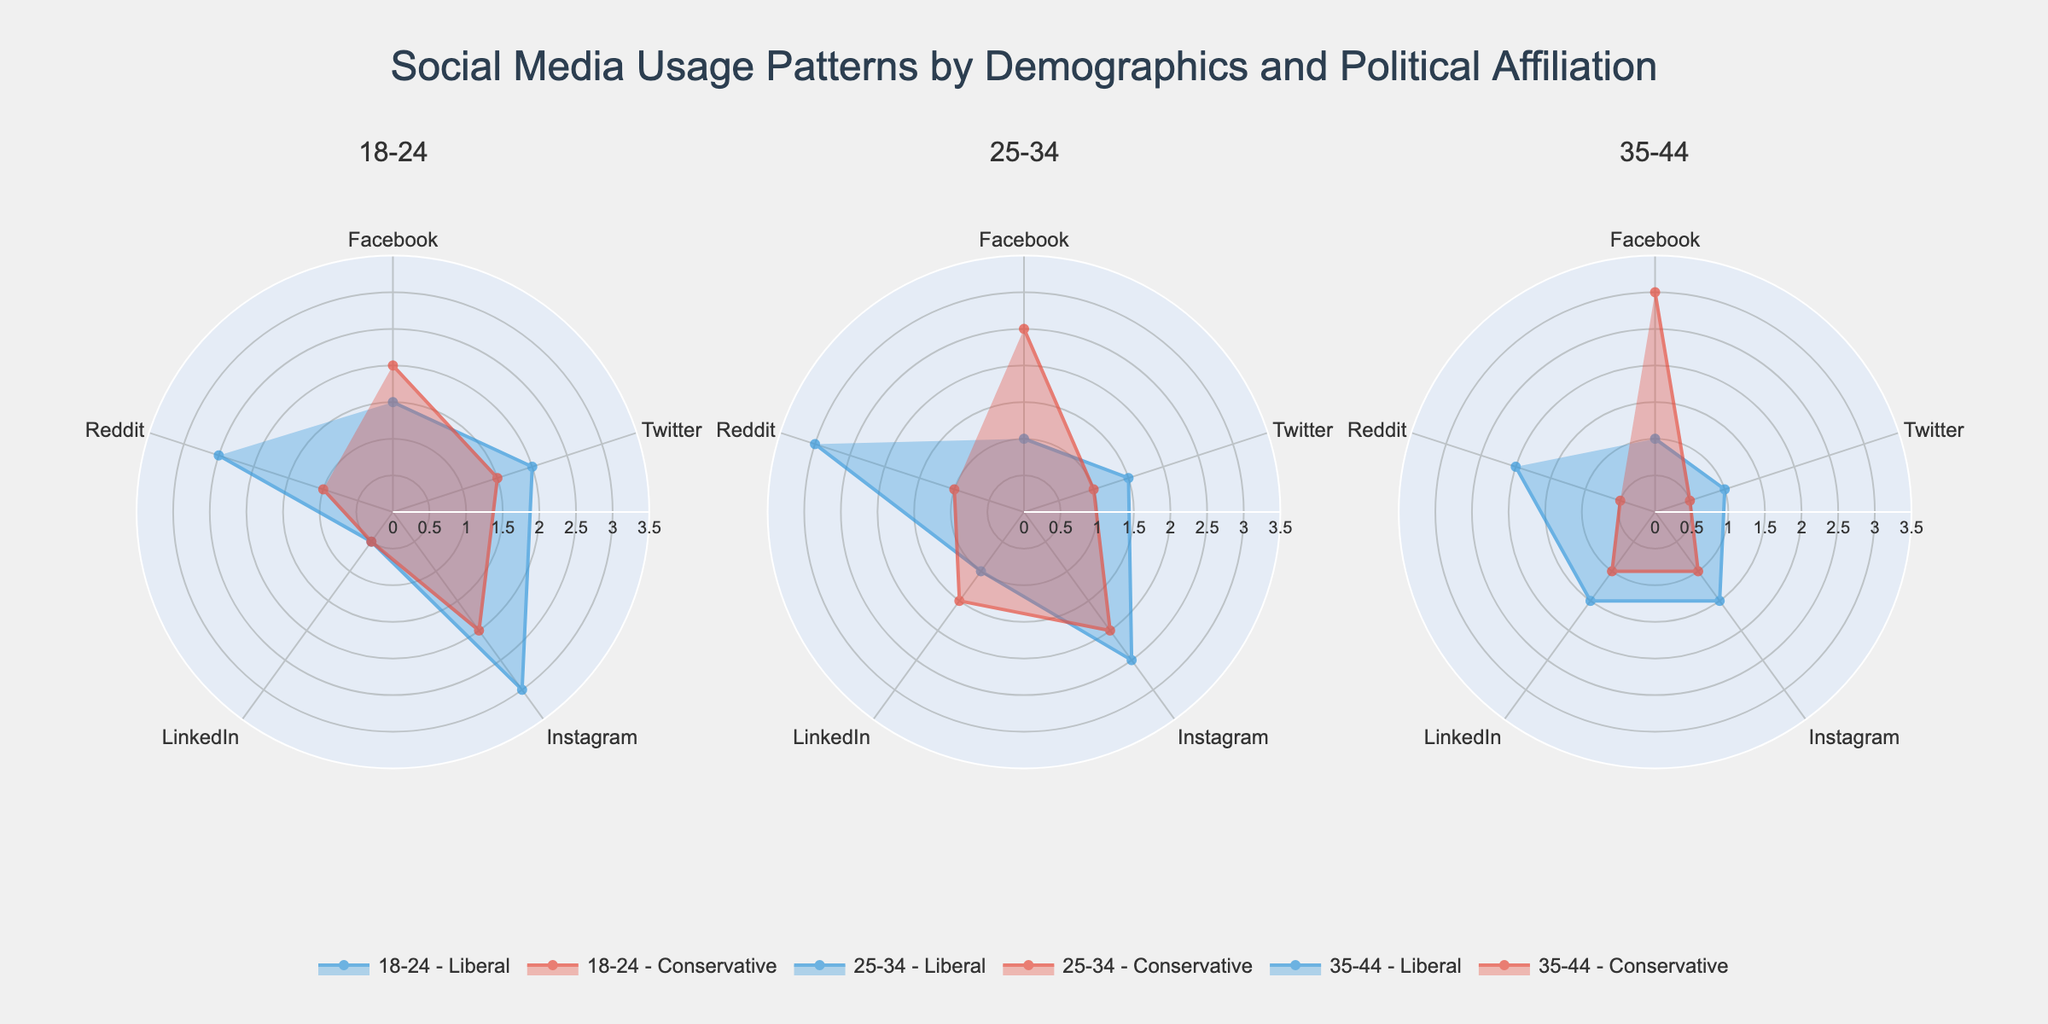Which age group and political affiliation spends the most time on Instagram? By looking at the plot, consider the radial distance for each demographic and political affiliation in relation to Instagram. The 18-24, Liberal group shows the highest radial distance for Instagram with 3.0 hours of average daily usage.
Answer: 18-24, Liberal Which platform has the lowest usage among 35-44 Conservatives? Locate the plot for 35-44 Conservatives and identify the platform with the shortest radial distance. It is indicated that Twitter has the lowest usage with 0.5 hours of average daily usage.
Answer: Twitter Compare the average daily usage of Reddit between 18-24 Liberals and Conservatives. Which group uses it more? Examine the radial distances for Reddit in the 18-24 demographic. The Liberal group has a radial distance of 2.5 hours while the Conservative group has a radial distance of 1.0 hour. Hence, 18-24 Liberals use Reddit more.
Answer: 18-24 Liberals What is the average daily usage of LinkedIn for 25-34 Conservatives? Simply check the radial distance for LinkedIn in the 25-34 Conservative plot within the radar chart. The figure indicates it at 1.5 hours.
Answer: 1.5 hours Which group exhibits the highest overall social media usage (sum of hours across all platforms)? Calculate the sum of hours for each group by adding the radial distances for all platforms. Compare the sums across all groups: 
- 18-24 Liberal: (1.5 + 2.0 + 3.0 + 0.5 + 2.5) = 9.5 
- 18-24 Conservative: (2.0 + 1.5 + 2.0 + 0.5 + 1.0) = 7.0 
- 25-34 Liberal: (1.0 + 1.5 + 2.5 + 1.0 + 3.0) = 9.0 
- 25-34 Conservative: (2.5 + 1.0 + 2.0 + 1.5 + 1.0) = 8.0 
- 35-44 Liberal: (1.0 + 1.0 + 1.5 + 1.5 + 2.0) = 7.0 
- 35-44 Conservative: (3.0 + 0.5 + 1.0 + 1.0 + 0.5) = 6.0 
Thus, 18-24 Liberals have the highest overall usage.
Answer: 18-24 Liberal In the 25-34 age group, which political affiliation uses Facebook more? Compare the radial distances for Facebook in the 25-34 age group for both political affiliations. The Conservative group has a higher radial distance with 2.5 hours compared to 1.0 hours for the Liberal group.
Answer: Conservative 